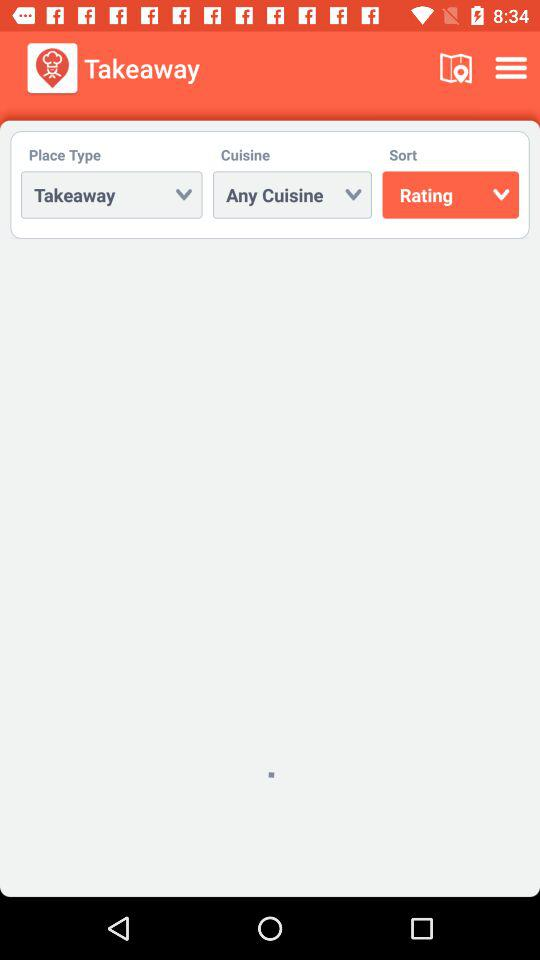Which cuisine is chosen? The chosen cuisine is "Any Cuisine". 